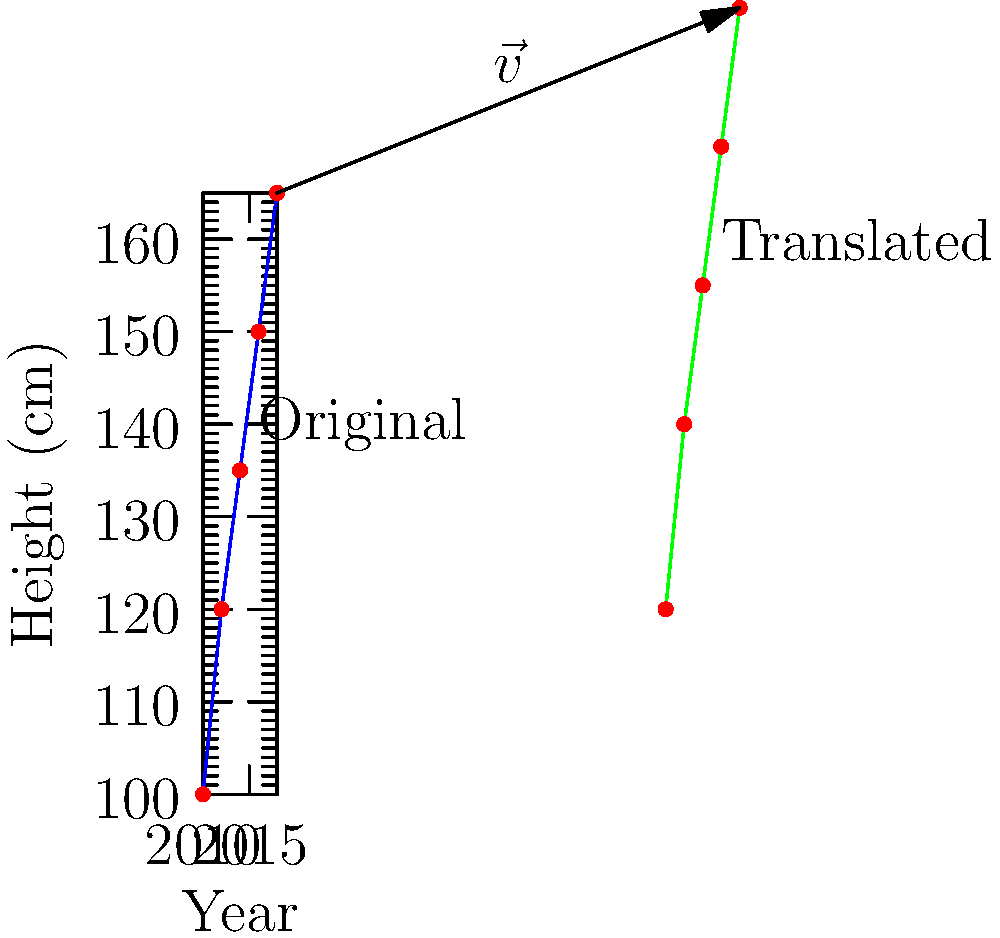As a longtime friend of the Setzer family, you've been entrusted with updating their children's growth chart. The original chart shows the height of the eldest Setzer child from 2010 to 2018. If you were to translate this growth chart by the vector $\vec{v} = (50, 20)$, what would be the coordinates of the final data point (originally at (2018, 165)) after the translation? To solve this problem, we need to understand the concept of translation in transformational geometry:

1. The original growth chart is plotted with years on the x-axis and heights on the y-axis.
2. The final data point on the original chart is at (2018, 165).
3. The translation vector $\vec{v} = (50, 20)$ means we need to:
   a. Add 50 to the x-coordinate
   b. Add 20 to the y-coordinate

4. Calculating the new coordinates:
   - New x-coordinate: $2018 + 50 = 2068$
   - New y-coordinate: $165 + 20 = 185$

5. Therefore, after translation, the final data point will be at (2068, 185).

This translation effectively moves the entire growth chart 50 units to the right and 20 units up, as shown by the green line in the diagram.
Answer: (2068, 185) 